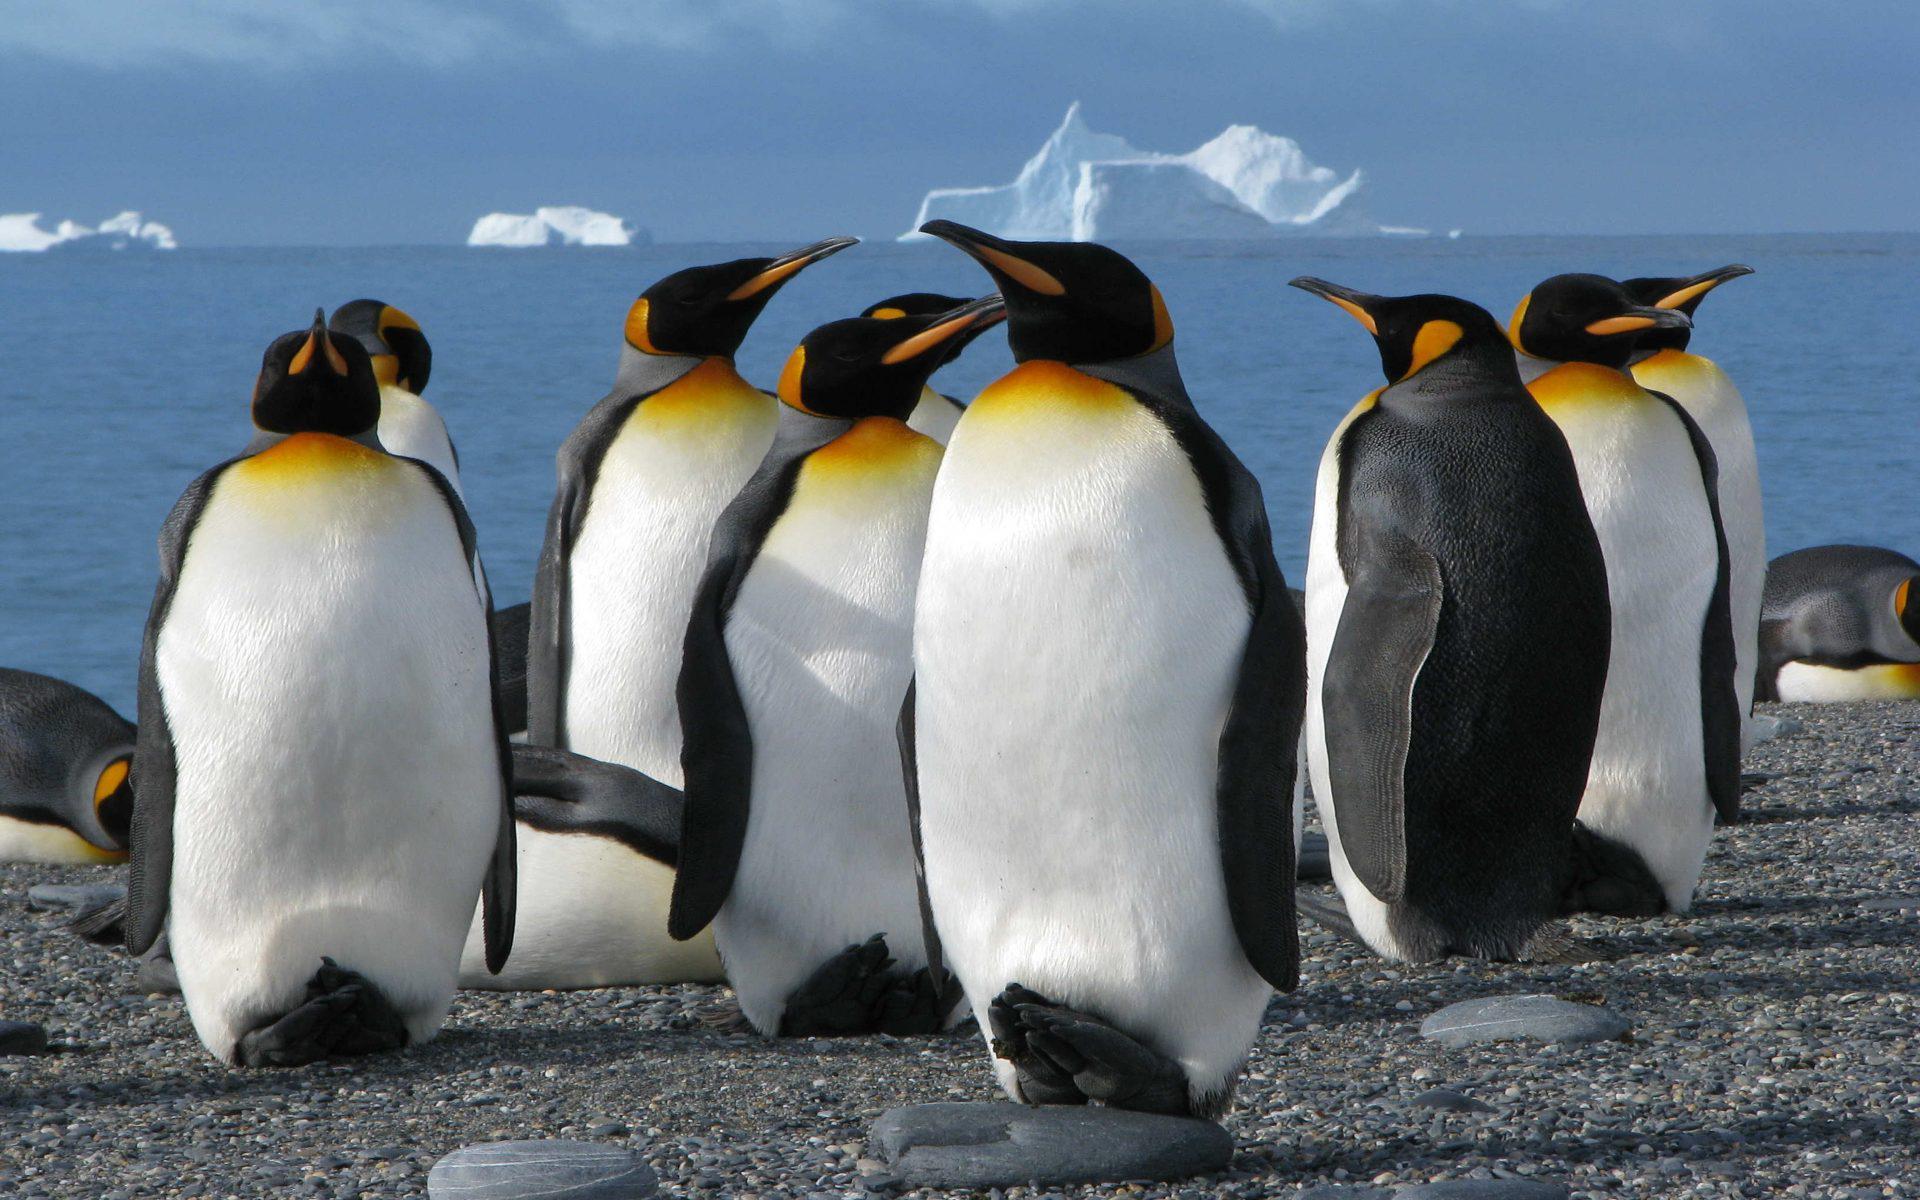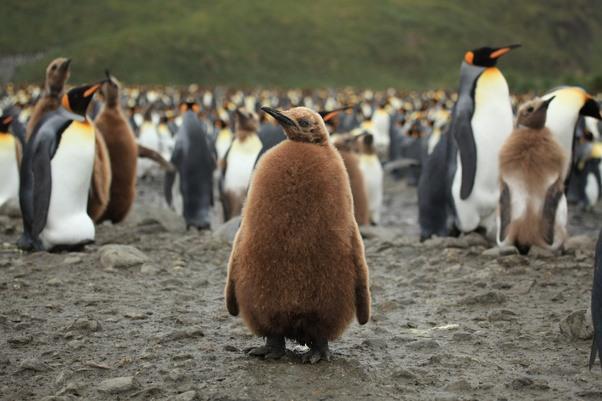The first image is the image on the left, the second image is the image on the right. Examine the images to the left and right. Is the description "There are exactly three animals in the image on the right." accurate? Answer yes or no. No. The first image is the image on the left, the second image is the image on the right. Assess this claim about the two images: "A penguin in the foreground is at least partly covered in brown fuzzy feathers.". Correct or not? Answer yes or no. Yes. 